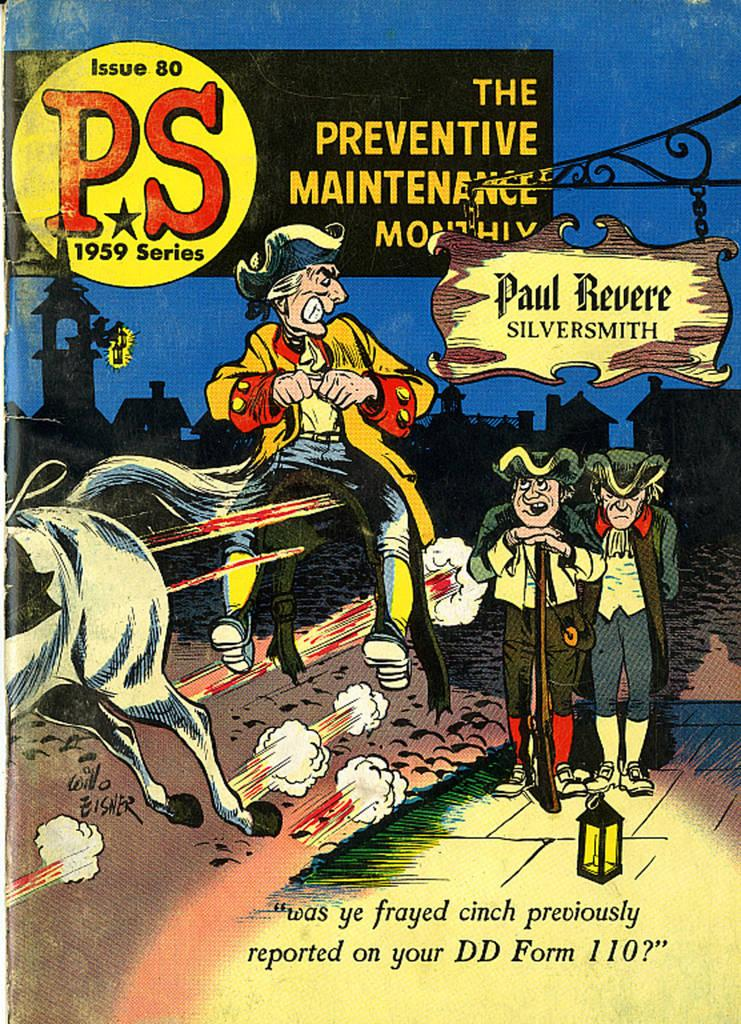<image>
Relay a brief, clear account of the picture shown. a book from a 1959 series with many characters on it 